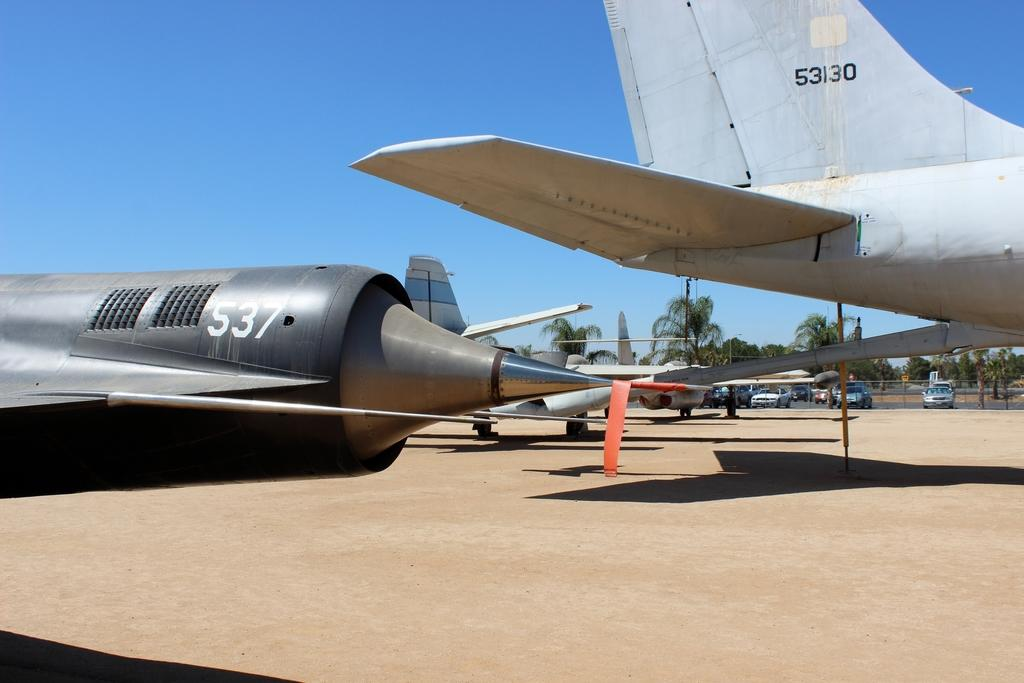Provide a one-sentence caption for the provided image. Airplanes sitting on the ground that are a silvery gray color and have 537 on one and 53130 on the other. 